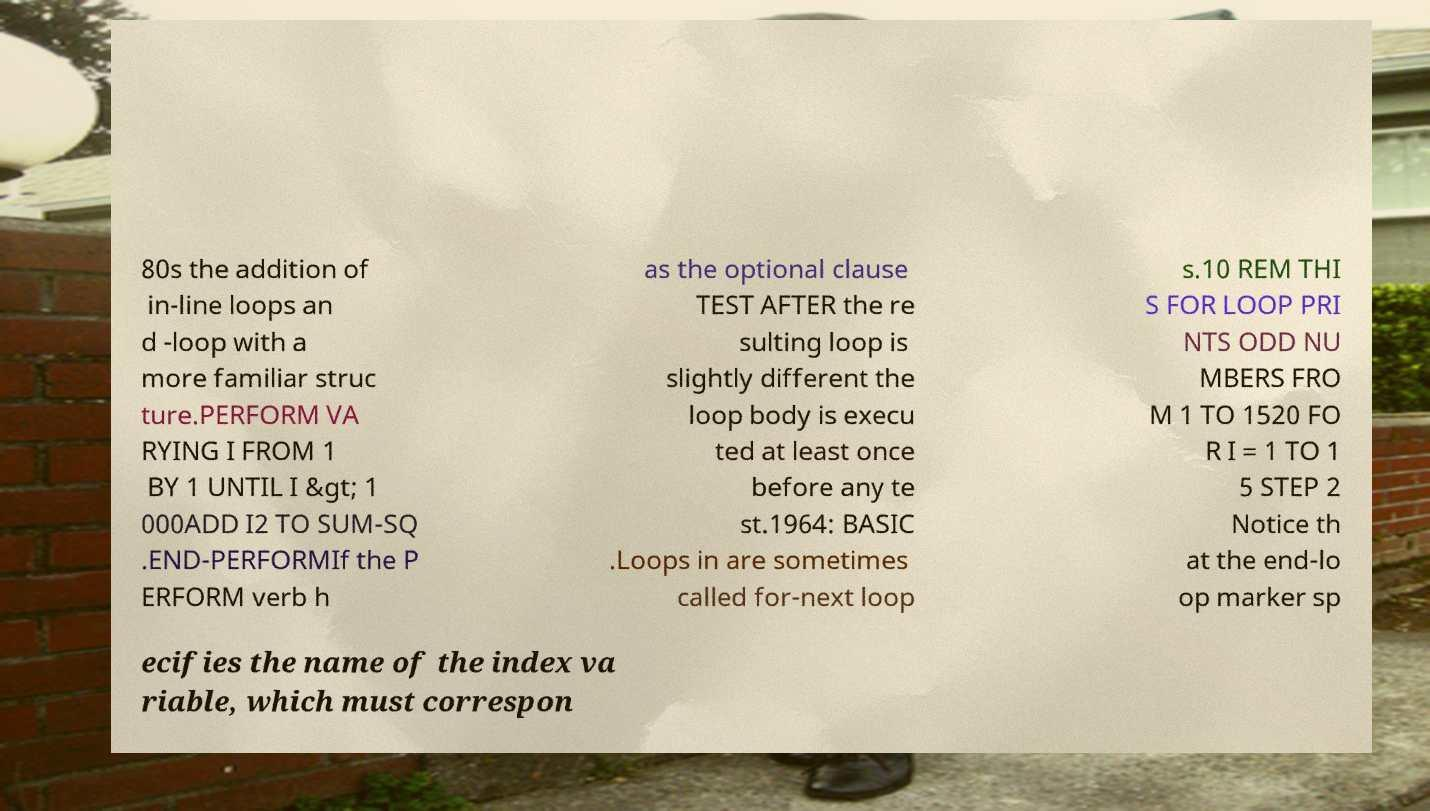There's text embedded in this image that I need extracted. Can you transcribe it verbatim? 80s the addition of in-line loops an d -loop with a more familiar struc ture.PERFORM VA RYING I FROM 1 BY 1 UNTIL I &gt; 1 000ADD I2 TO SUM-SQ .END-PERFORMIf the P ERFORM verb h as the optional clause TEST AFTER the re sulting loop is slightly different the loop body is execu ted at least once before any te st.1964: BASIC .Loops in are sometimes called for-next loop s.10 REM THI S FOR LOOP PRI NTS ODD NU MBERS FRO M 1 TO 1520 FO R I = 1 TO 1 5 STEP 2 Notice th at the end-lo op marker sp ecifies the name of the index va riable, which must correspon 